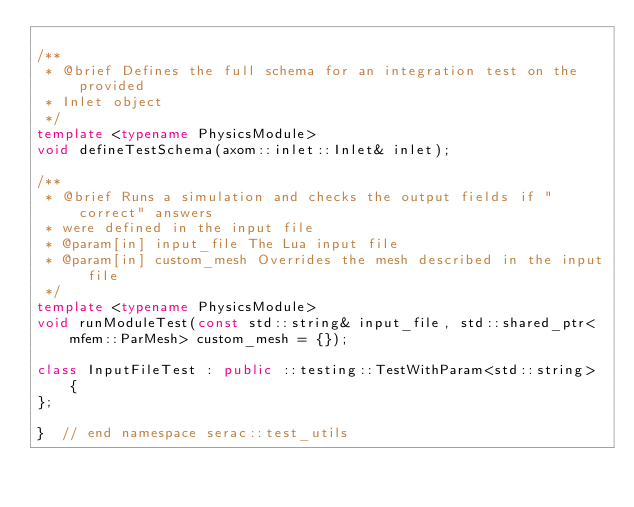Convert code to text. <code><loc_0><loc_0><loc_500><loc_500><_C++_>
/**
 * @brief Defines the full schema for an integration test on the provided
 * Inlet object
 */
template <typename PhysicsModule>
void defineTestSchema(axom::inlet::Inlet& inlet);

/**
 * @brief Runs a simulation and checks the output fields if "correct" answers
 * were defined in the input file
 * @param[in] input_file The Lua input file
 * @param[in] custom_mesh Overrides the mesh described in the input file
 */
template <typename PhysicsModule>
void runModuleTest(const std::string& input_file, std::shared_ptr<mfem::ParMesh> custom_mesh = {});

class InputFileTest : public ::testing::TestWithParam<std::string> {
};

}  // end namespace serac::test_utils
</code> 